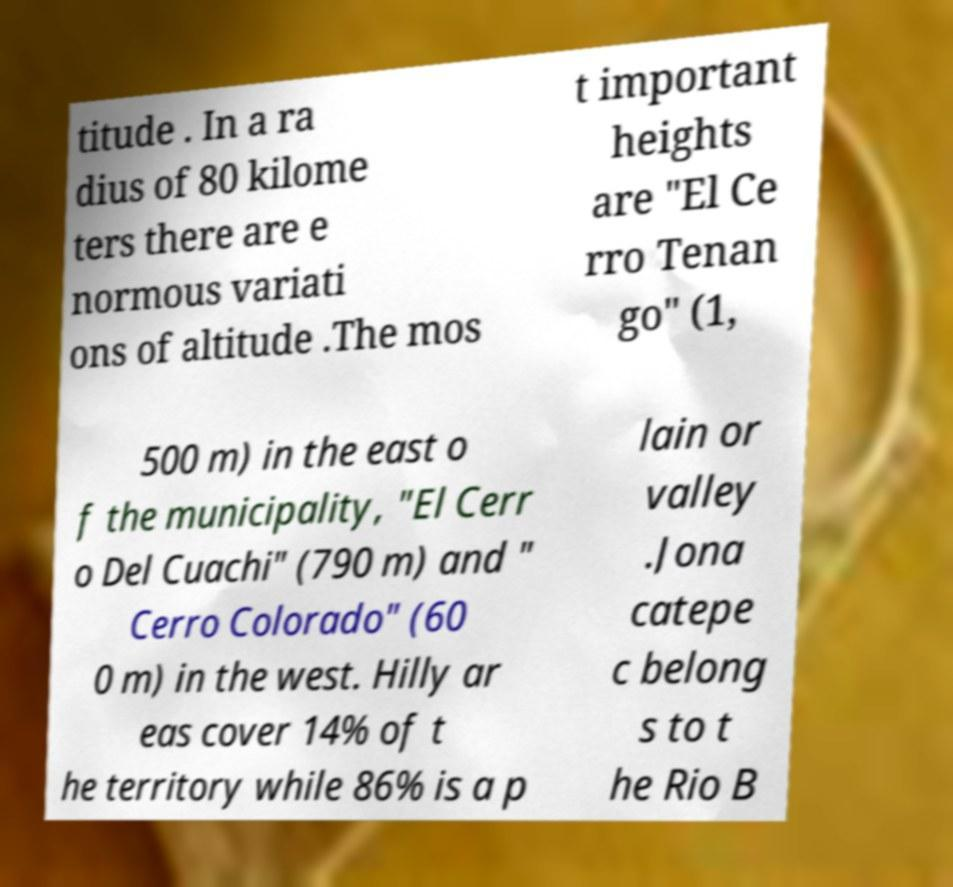Can you accurately transcribe the text from the provided image for me? titude . In a ra dius of 80 kilome ters there are e normous variati ons of altitude .The mos t important heights are "El Ce rro Tenan go" (1, 500 m) in the east o f the municipality, "El Cerr o Del Cuachi" (790 m) and " Cerro Colorado" (60 0 m) in the west. Hilly ar eas cover 14% of t he territory while 86% is a p lain or valley .Jona catepe c belong s to t he Rio B 